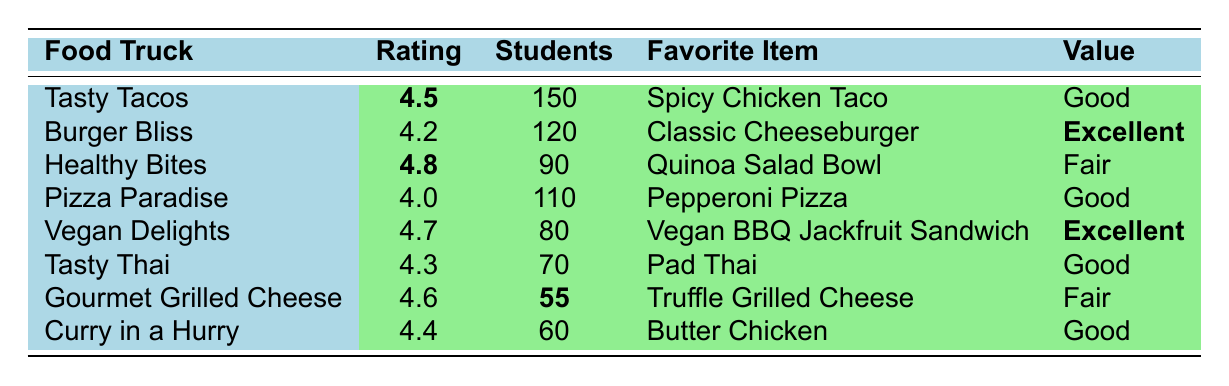What is the highest satisfaction rating among the food trucks? The highest satisfaction rating in the table is 4.8, which belongs to "Healthy Bites."
Answer: 4.8 How many students were served by the "Tasty Tacos"? The table shows that "Tasty Tacos" served 150 students.
Answer: 150 Which food truck has the favorite menu item of "Classic Cheeseburger"? The food truck with the favorite menu item of "Classic Cheeseburger" is "Burger Bliss."
Answer: Burger Bliss What is the average satisfaction rating of all food trucks listed? The satisfaction ratings are 4.5, 4.2, 4.8, 4.0, 4.7, 4.3, 4.6, and 4.4. To find the average, sum these ratings: (4.5 + 4.2 + 4.8 + 4.0 + 4.7 + 4.3 + 4.6 + 4.4) = 35.5. There are 8 food trucks, so the average is 35.5 / 8 = 4.4375.
Answer: 4.44 Is there a food truck that received a "Fair" value rating? Yes, both "Healthy Bites" and "Gourmet Grilled Cheese" received a "Fair" value rating.
Answer: Yes Which food truck served the fewest students? "Gourmet Grilled Cheese" served the fewest students at 55.
Answer: 55 What is the total number of students served by all food trucks? To find the total number of students served, sum the students served by each truck: 150 + 120 + 90 + 110 + 80 + 70 + 55 + 60 = 775.
Answer: 775 How many food trucks have a satisfaction rating above 4.5? The food trucks with ratings above 4.5 are "Healthy Bites," "Vegan Delights," "Tasty Tacos," and "Gourmet Grilled Cheese," totaling four trucks.
Answer: 4 Which food truck's students commented on having a variety of flavors? The comments about having a variety of flavors are from "Tasty Tacos."
Answer: Tasty Tacos What is the difference between the highest and lowest satisfaction rating? The highest rating is 4.8 (Healthy Bites) and the lowest rating is 4.0 (Pizza Paradise). The difference is 4.8 - 4.0 = 0.8.
Answer: 0.8 How many food trucks provided "Good" value for money? The food trucks providing "Good" value for money are "Tasty Tacos," "Pizza Paradise," and "Curry in a Hurry," totaling three trucks.
Answer: 3 